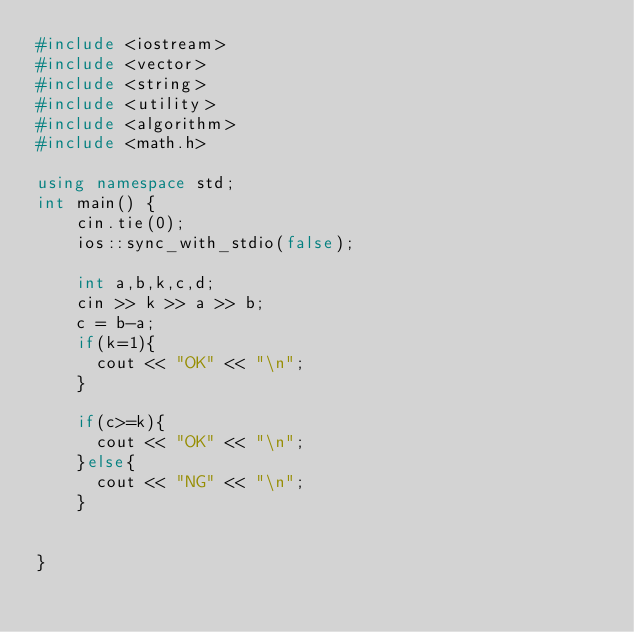<code> <loc_0><loc_0><loc_500><loc_500><_C++_>#include <iostream>
#include <vector>
#include <string>
#include <utility>
#include <algorithm>
#include <math.h>
 
using namespace std;
int main() {
	cin.tie(0);
   	ios::sync_with_stdio(false);
 
	int a,b,k,c,d;
	cin >> k >> a >> b;
    c = b-a;
    if(k=1){
      cout << "OK" << "\n";
    }
    
    if(c>=k){
      cout << "OK" << "\n";
    }else{
      cout << "NG" << "\n";
    }
  
  
}</code> 